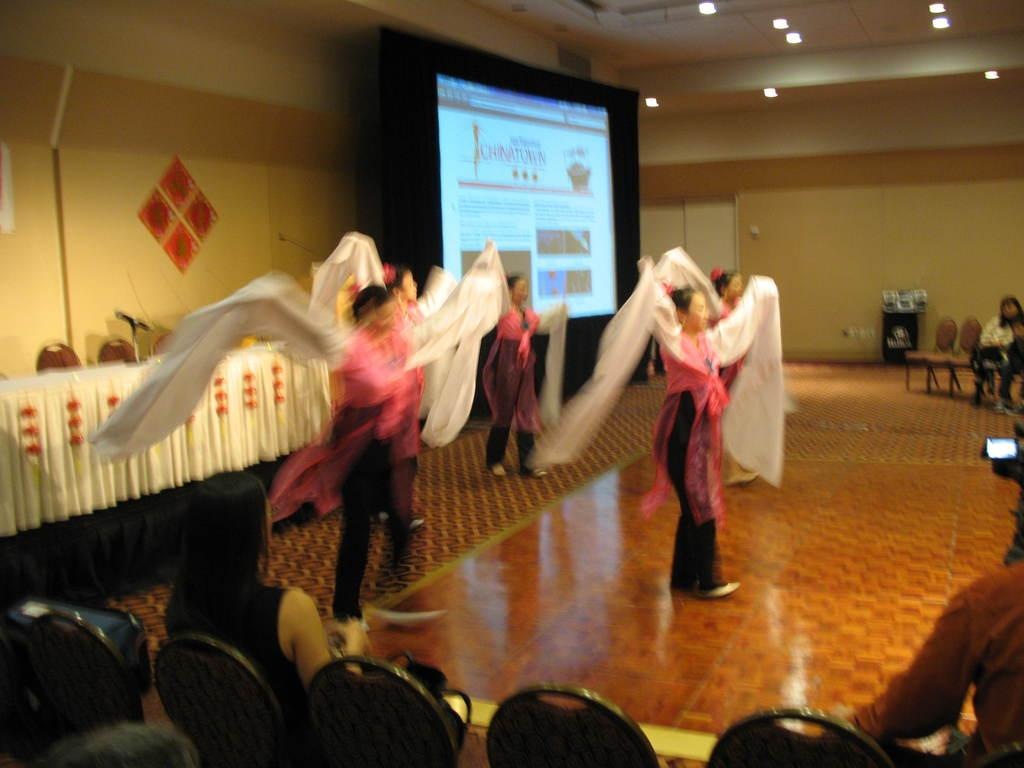What is happening on the stage in the image? There are people standing on the stage in the image. What is located behind the stage? There is a projector screen behind the stage. What type of seating is available for the audience? Chairs are present on the floor for the audience to sit on. How are the chairs being used in the image? People are sitting on the chairs. How is the steam being used to treat the audience in the image? There is no steam present in the image, and therefore it cannot be used to treat the audience. 